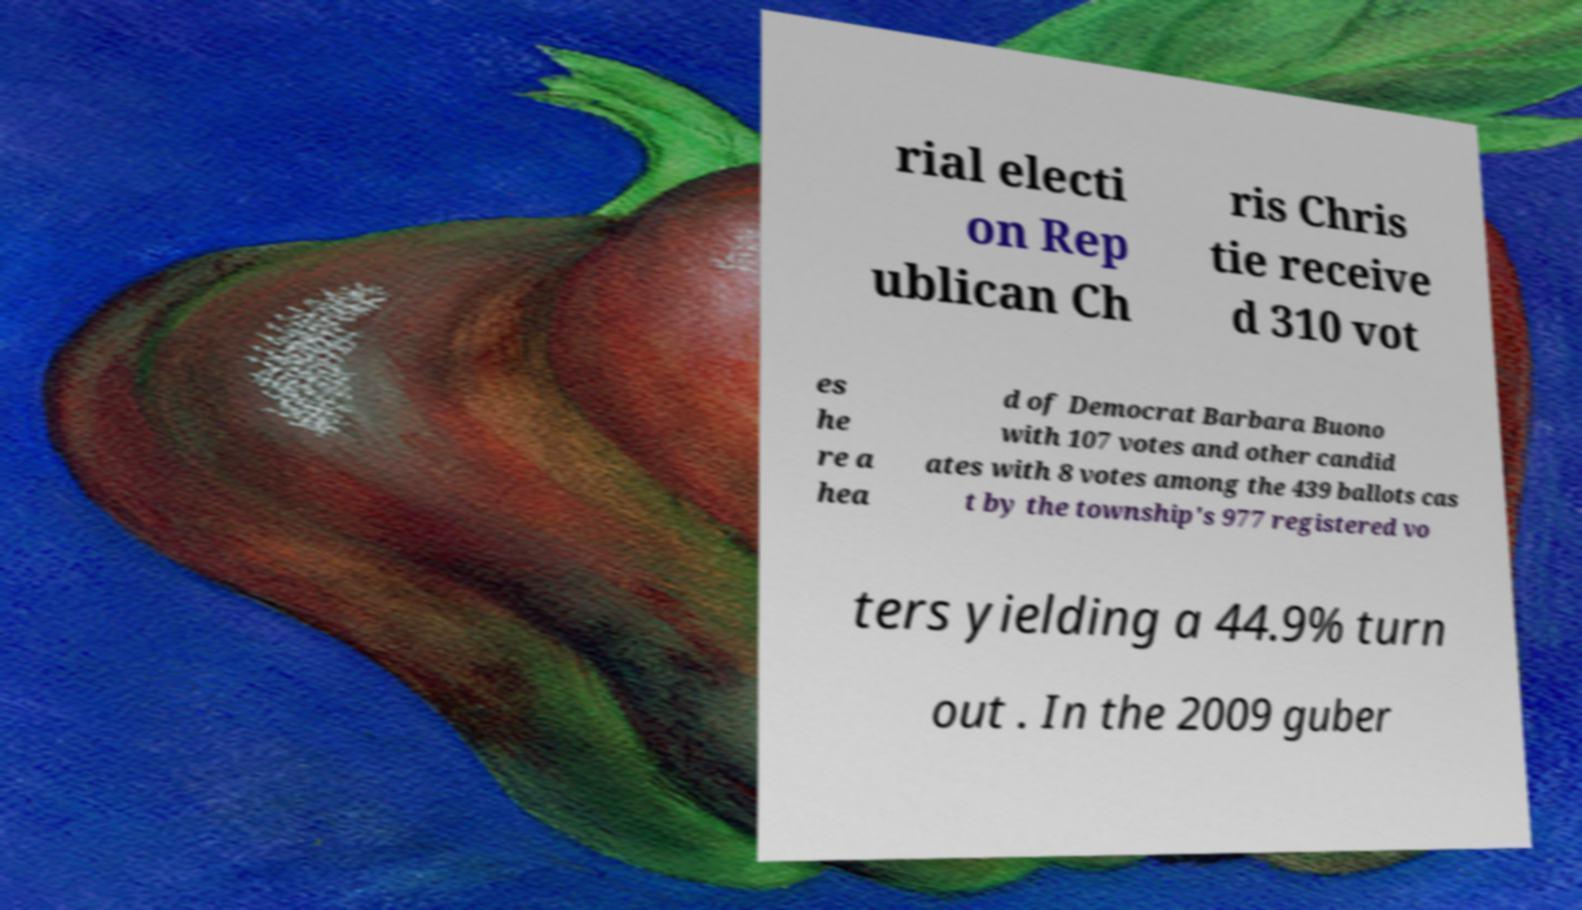What messages or text are displayed in this image? I need them in a readable, typed format. rial electi on Rep ublican Ch ris Chris tie receive d 310 vot es he re a hea d of Democrat Barbara Buono with 107 votes and other candid ates with 8 votes among the 439 ballots cas t by the township's 977 registered vo ters yielding a 44.9% turn out . In the 2009 guber 